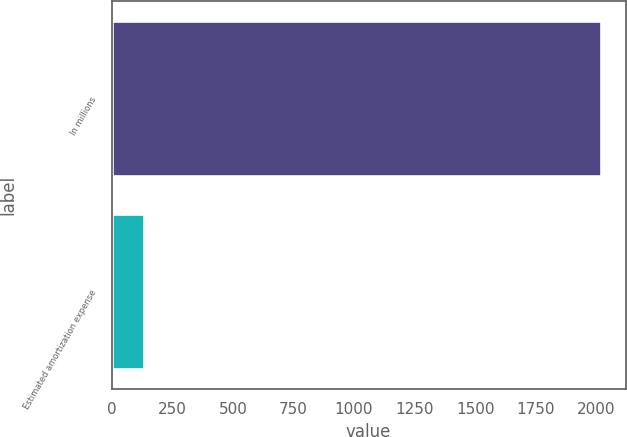<chart> <loc_0><loc_0><loc_500><loc_500><bar_chart><fcel>In millions<fcel>Estimated amortization expense<nl><fcel>2020<fcel>133.7<nl></chart> 